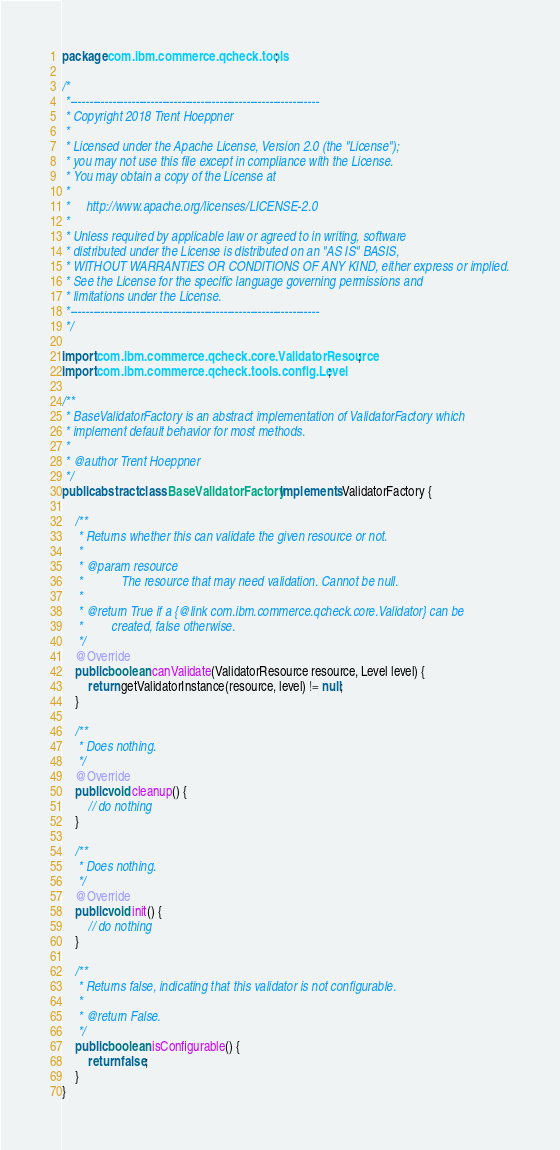<code> <loc_0><loc_0><loc_500><loc_500><_Java_>package com.ibm.commerce.qcheck.tools;

/*
 *-----------------------------------------------------------------
 * Copyright 2018 Trent Hoeppner
 *
 * Licensed under the Apache License, Version 2.0 (the "License");
 * you may not use this file except in compliance with the License.
 * You may obtain a copy of the License at
 * 
 *     http://www.apache.org/licenses/LICENSE-2.0
 * 
 * Unless required by applicable law or agreed to in writing, software
 * distributed under the License is distributed on an "AS IS" BASIS,
 * WITHOUT WARRANTIES OR CONDITIONS OF ANY KIND, either express or implied.
 * See the License for the specific language governing permissions and
 * limitations under the License.
 *-----------------------------------------------------------------
 */

import com.ibm.commerce.qcheck.core.ValidatorResource;
import com.ibm.commerce.qcheck.tools.config.Level;

/**
 * BaseValidatorFactory is an abstract implementation of ValidatorFactory which
 * implement default behavior for most methods.
 * 
 * @author Trent Hoeppner
 */
public abstract class BaseValidatorFactory implements ValidatorFactory {

	/**
	 * Returns whether this can validate the given resource or not.
	 * 
	 * @param resource
	 *            The resource that may need validation. Cannot be null.
	 * 
	 * @return True if a {@link com.ibm.commerce.qcheck.core.Validator} can be
	 *         created, false otherwise.
	 */
	@Override
	public boolean canValidate(ValidatorResource resource, Level level) {
		return getValidatorInstance(resource, level) != null;
	}

	/**
	 * Does nothing.
	 */
	@Override
	public void cleanup() {
		// do nothing
	}

	/**
	 * Does nothing.
	 */
	@Override
	public void init() {
		// do nothing
	}

	/**
	 * Returns false, indicating that this validator is not configurable.
	 * 
	 * @return False.
	 */
	public boolean isConfigurable() {
		return false;
	}
}
</code> 